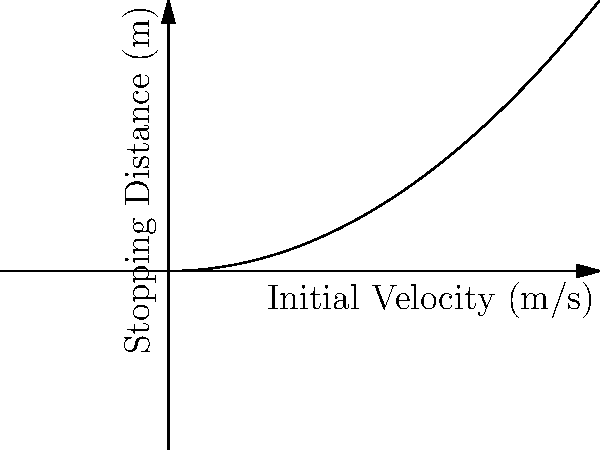In a recent vehicular manslaughter case, the prosecution argues that the defendant had ample time to stop before hitting the victim. The graph shows the relationship between a vehicle's initial velocity and its stopping distance. If the defendant's car was traveling at 15 m/s, what would be the approximate stopping distance? How might this information be used in the defense strategy? To answer this question, we need to analyze the graph and extract the relevant information. Let's break it down step-by-step:

1) The graph shows a non-linear relationship between initial velocity and stopping distance. This relationship appears to be quadratic, which is consistent with the physics of braking.

2) We need to find the stopping distance for an initial velocity of 15 m/s.

3) Tracing a vertical line from 15 m/s on the x-axis until it intersects the curve, and then tracing a horizontal line to the y-axis, we can estimate the stopping distance.

4) The stopping distance appears to be approximately 11.25 meters (visually estimated from the graph).

5) This relationship can be expressed mathematically as:

   $$ d = k v^2 $$

   where $d$ is the stopping distance, $v$ is the initial velocity, and $k$ is a constant that depends on factors like road conditions and vehicle characteristics.

6) In terms of defense strategy, this information could be used to:
   a) Demonstrate that the stopping distance increases rapidly with speed, making it difficult to react in time at higher speeds.
   b) Argue that external factors (road conditions, weather, etc.) could have increased the stopping distance beyond what's shown in this ideal scenario.
   c) Highlight the complexity of split-second decision-making in high-speed situations.
Answer: Approximately 11.25 meters 